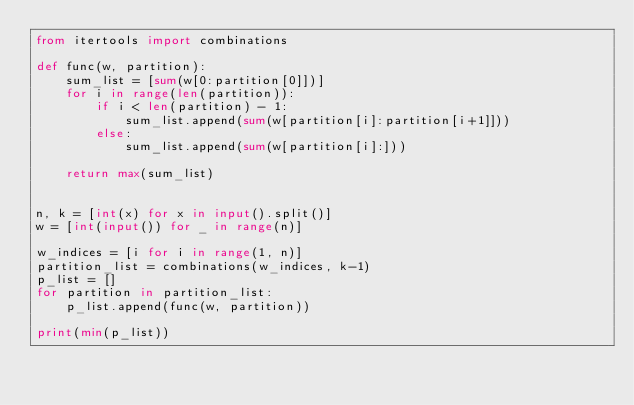Convert code to text. <code><loc_0><loc_0><loc_500><loc_500><_Python_>from itertools import combinations

def func(w, partition):
    sum_list = [sum(w[0:partition[0]])]
    for i in range(len(partition)):
        if i < len(partition) - 1:
            sum_list.append(sum(w[partition[i]:partition[i+1]]))
        else:
            sum_list.append(sum(w[partition[i]:]))

    return max(sum_list)


n, k = [int(x) for x in input().split()]
w = [int(input()) for _ in range(n)]

w_indices = [i for i in range(1, n)]
partition_list = combinations(w_indices, k-1)
p_list = []
for partition in partition_list:
    p_list.append(func(w, partition))

print(min(p_list))
</code> 